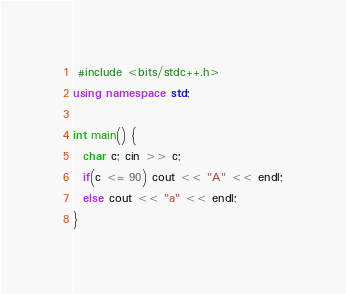Convert code to text. <code><loc_0><loc_0><loc_500><loc_500><_C++_> #include <bits/stdc++.h>
using namespace std;

int main() {
  char c; cin >> c;
  if(c <= 90) cout << "A" << endl;
  else cout << "a" << endl;
}
</code> 